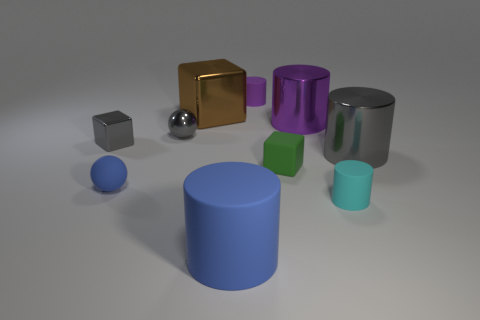Subtract all tiny cyan rubber cylinders. How many cylinders are left? 4 Subtract all gray cylinders. How many cylinders are left? 4 Subtract 2 cylinders. How many cylinders are left? 3 Subtract all brown cylinders. Subtract all cyan cubes. How many cylinders are left? 5 Subtract all cubes. How many objects are left? 7 Add 9 small metallic balls. How many small metallic balls exist? 10 Subtract 0 red blocks. How many objects are left? 10 Subtract all purple matte balls. Subtract all green rubber blocks. How many objects are left? 9 Add 1 large brown objects. How many large brown objects are left? 2 